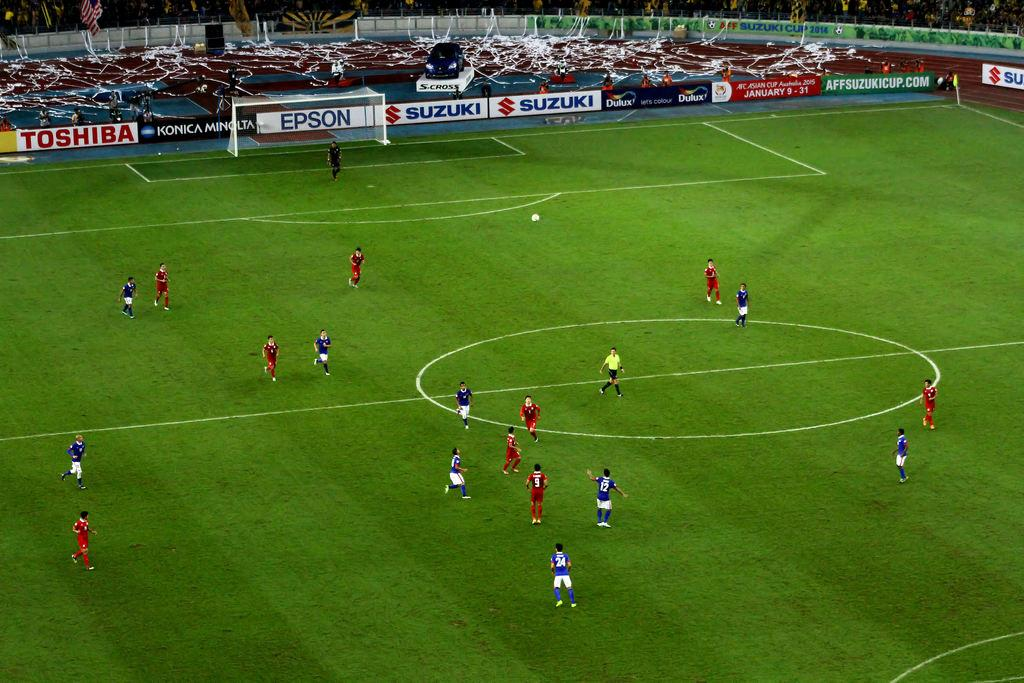Provide a one-sentence caption for the provided image. A soccer game takes place while there are advertisements for Toshiba and Epson in the background. 